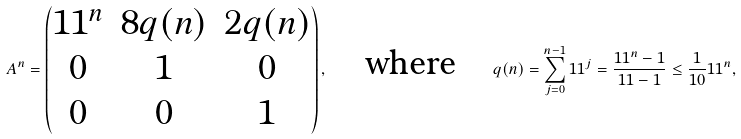<formula> <loc_0><loc_0><loc_500><loc_500>A ^ { n } = \begin{pmatrix} 1 1 ^ { n } & 8 q ( n ) & 2 q ( n ) \\ 0 & 1 & 0 \\ 0 & 0 & 1 \end{pmatrix} , \quad \text {where} \quad q ( n ) = \sum _ { j = 0 } ^ { n - 1 } 1 1 ^ { j } = \frac { 1 1 ^ { n } - 1 } { 1 1 - 1 } \leq \frac { 1 } { 1 0 } 1 1 ^ { n } ,</formula> 